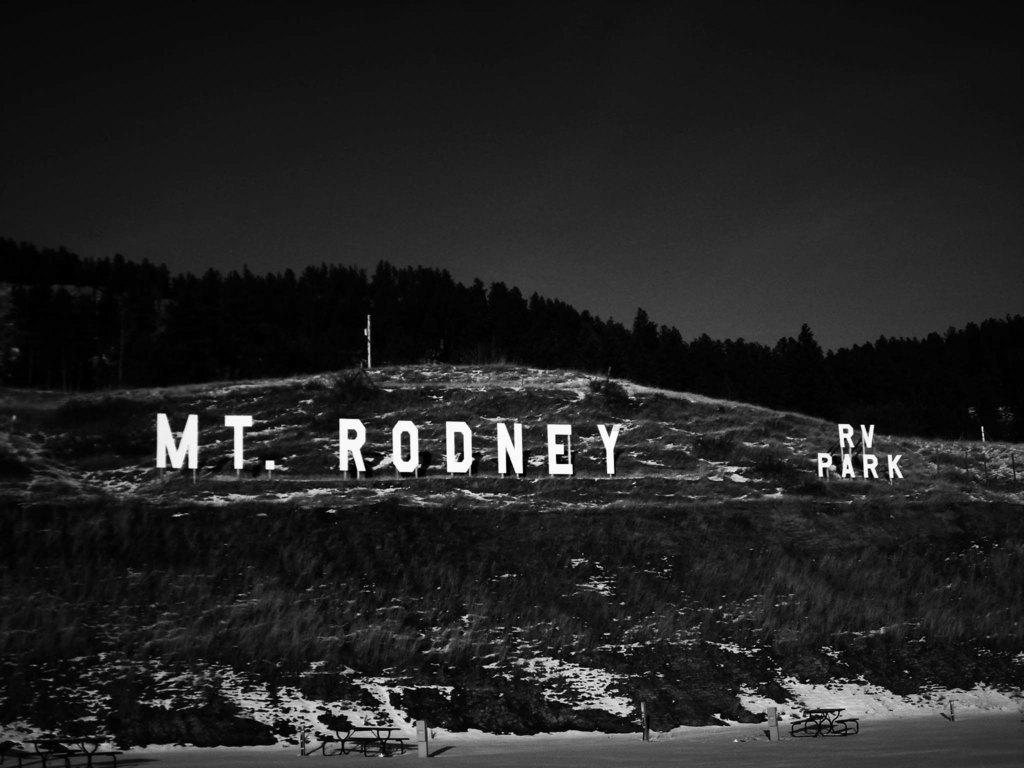<image>
Create a compact narrative representing the image presented. a sign on the side of a hill titled Mt. Rodney RV Park 